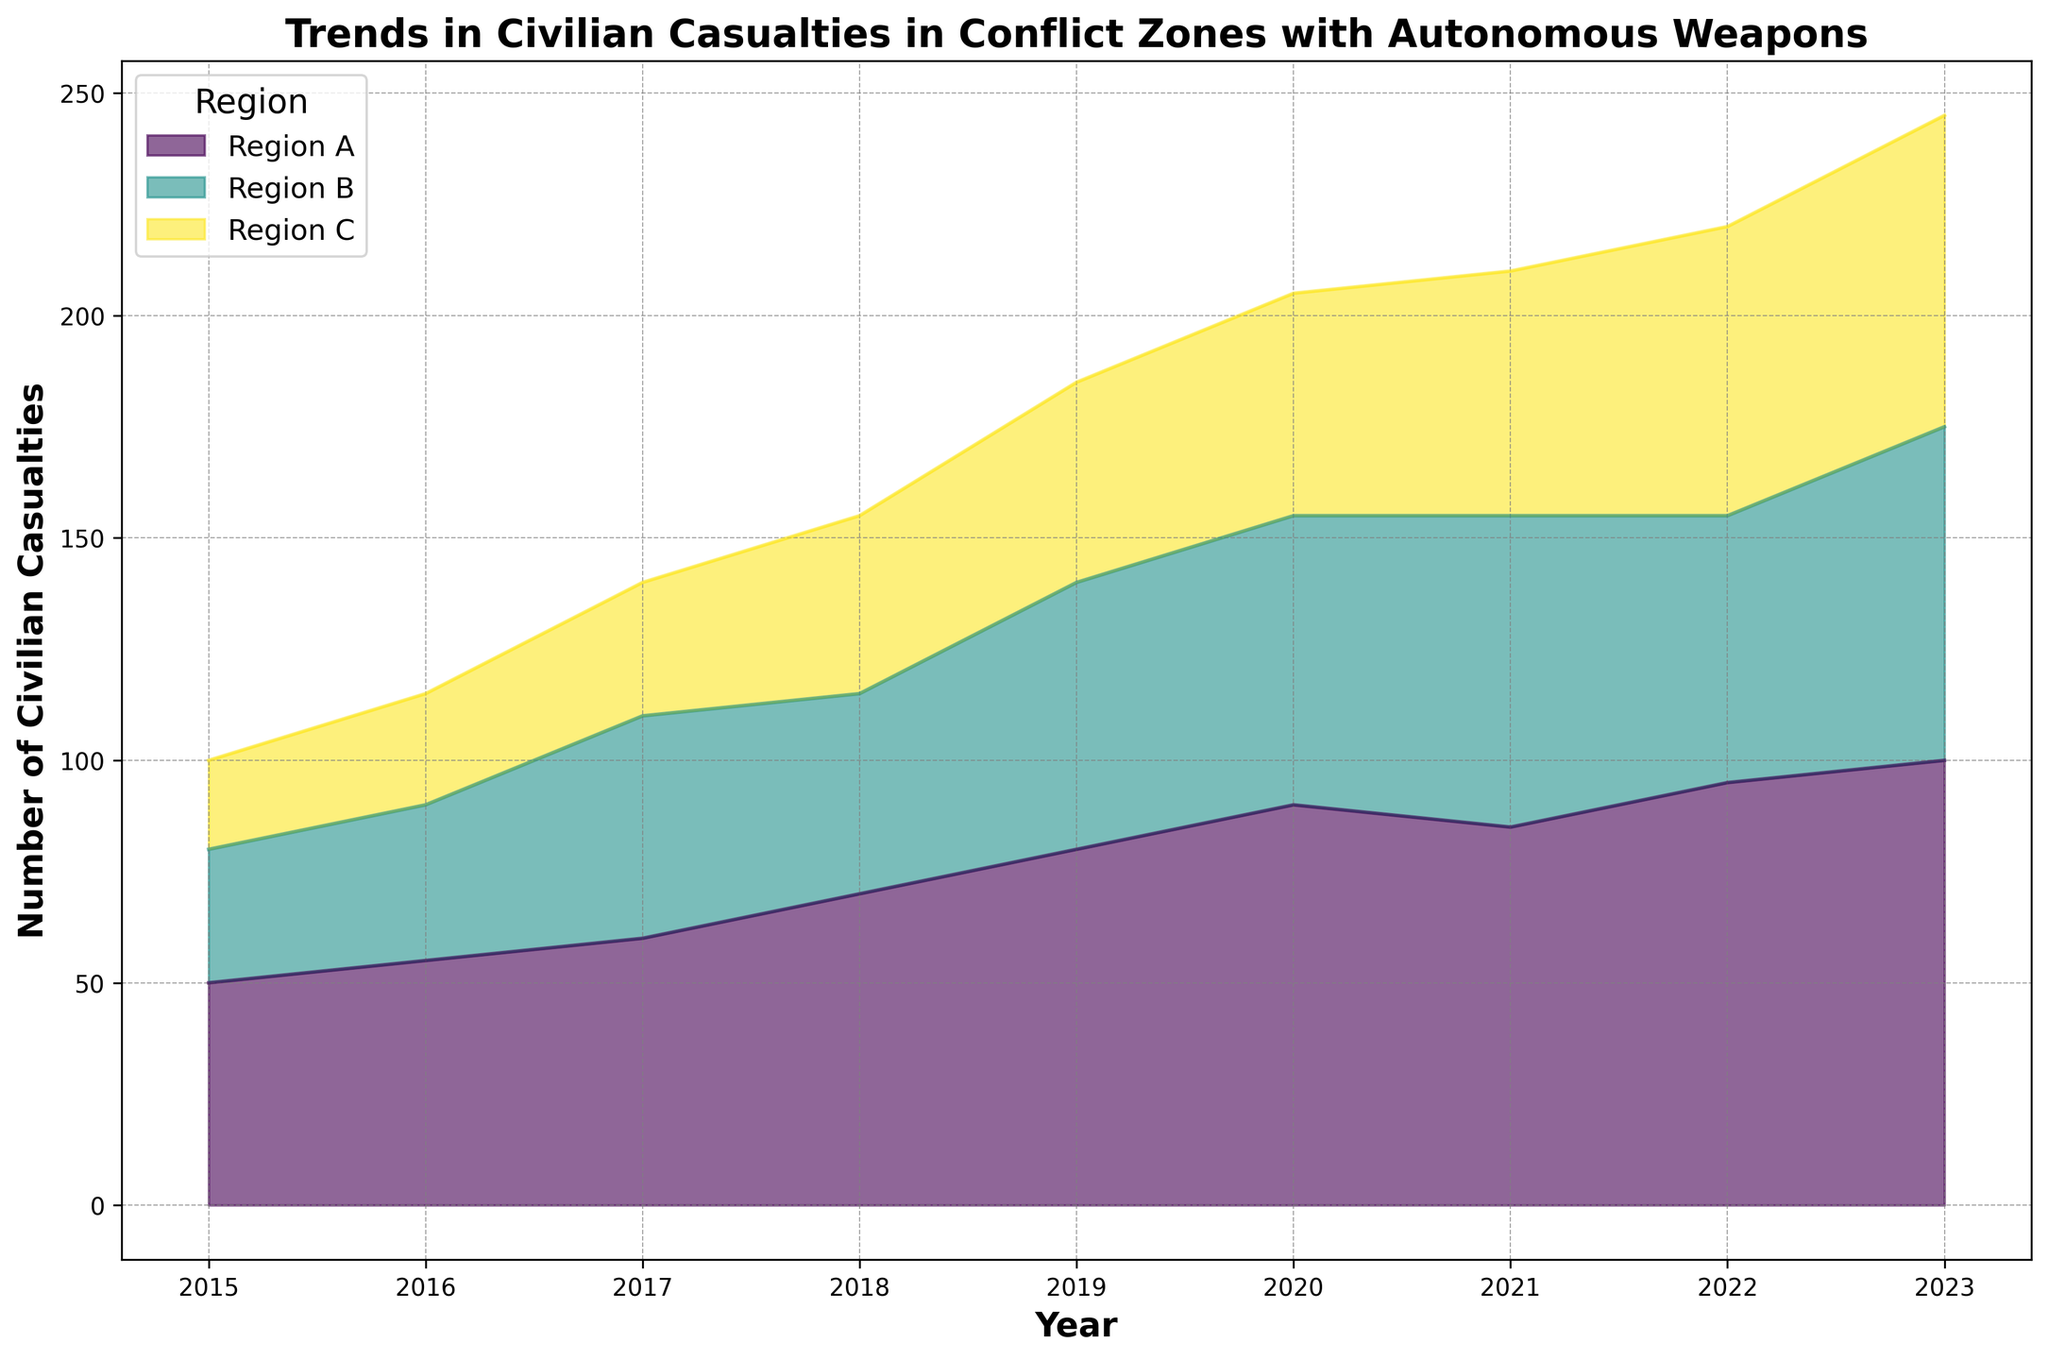Which region had the highest number of civilian casualties in 2023? By examining the year 2023 on the x-axis and looking for the highest point on the y-axis among all regions, we can see that Region A has the highest number of civilian casualties.
Answer: Region A How did the number of casualties in Region C change from 2015 to 2023? To determine the change, subtract the number of casualties in 2015 from the number of casualties in 2023 for Region C: 70 (2023) - 20 (2015).
Answer: Increased by 50 Which year saw the highest total number of civilian casualties across all regions? Sum the number of casualties for each region per year and compare. 2023 yields: 100 (A) + 75 (B) + 70 (C) = 245; this is the highest compared to other years.
Answer: 2023 Did Region B see a higher number of casualties in 2022 compared to 2018? Compare the points representing Region B for the years 2018 and 2022. 2022 shows 60 casualties, whereas 2018 shows 45 casualties.
Answer: Yes What is the average number of casualties in Region A over the given period? Sum the casualties in Region A across all years and divide by the number of years: (50+55+60+70+80+90+85+95+100)/9 = 76.67.
Answer: 76.67 Which region had the least variation in the number of casualties year over year? By visually comparing the heights of the areas for all regions, it is noticeable that Region C's area is relatively more stable (less extreme peaks).
Answer: Region C Between 2019 and 2020, which region showed the highest increase in casualties? Calculate the year-over-year difference for each region: 
Region A: 90 - 80 = 10,
Region B: 65 - 60 = 5,
Region C: 50 - 45 = 5. Region A had the highest increase.
Answer: Region A Compare the trends in civilian casualties between Region A and Region B from 2015 to 2023. How do they differ? Both trends generally increase, but Region A rises more sharply and consistently, especially between 2018 and 2023. Region B has a slight dip in 2018 before increasing again. Region A's trend is more linear whereas Region B's is less consistent.
Answer: Region A has a steeper, more consistent increase How many total civilian casualties were recorded across all regions in 2017? Sum the casualties for all regions in 2017: 60 (A) + 50 (B) + 30 (C) = 140.
Answer: 140 What trend can be observed regarding Region C's civilian casualties from 2021 to 2023? Observe Region C's values from 2021 (55) to 2023 (70): There is a noticeable increase over these years.
Answer: Increasing trend 